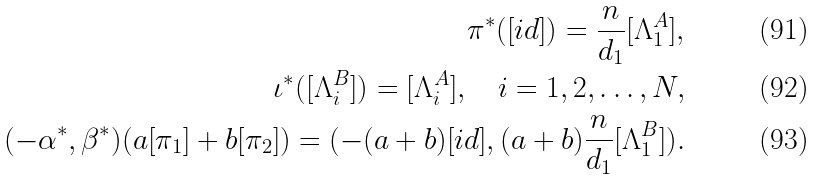<formula> <loc_0><loc_0><loc_500><loc_500>\pi ^ { * } ( [ i d ] ) = \frac { n } { d _ { 1 } } [ \Lambda _ { 1 } ^ { A } ] , \\ \iota ^ { * } ( [ \Lambda _ { i } ^ { B } ] ) = [ \Lambda _ { i } ^ { A } ] , \quad i = 1 , 2 , \dots , N , \\ ( - \alpha ^ { * } , \beta ^ { * } ) ( a [ \pi _ { 1 } ] + b [ \pi _ { 2 } ] ) = ( - ( a + b ) [ i d ] , ( a + b ) \frac { n } { d _ { 1 } } [ \Lambda _ { 1 } ^ { B } ] ) .</formula> 